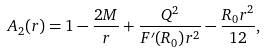Convert formula to latex. <formula><loc_0><loc_0><loc_500><loc_500>A _ { 2 } ( r ) = 1 - \frac { 2 M } { r } + \frac { Q ^ { 2 } } { F ^ { \prime } ( R _ { 0 } ) r ^ { 2 } } - \frac { R _ { 0 } r ^ { 2 } } { 1 2 } ,</formula> 